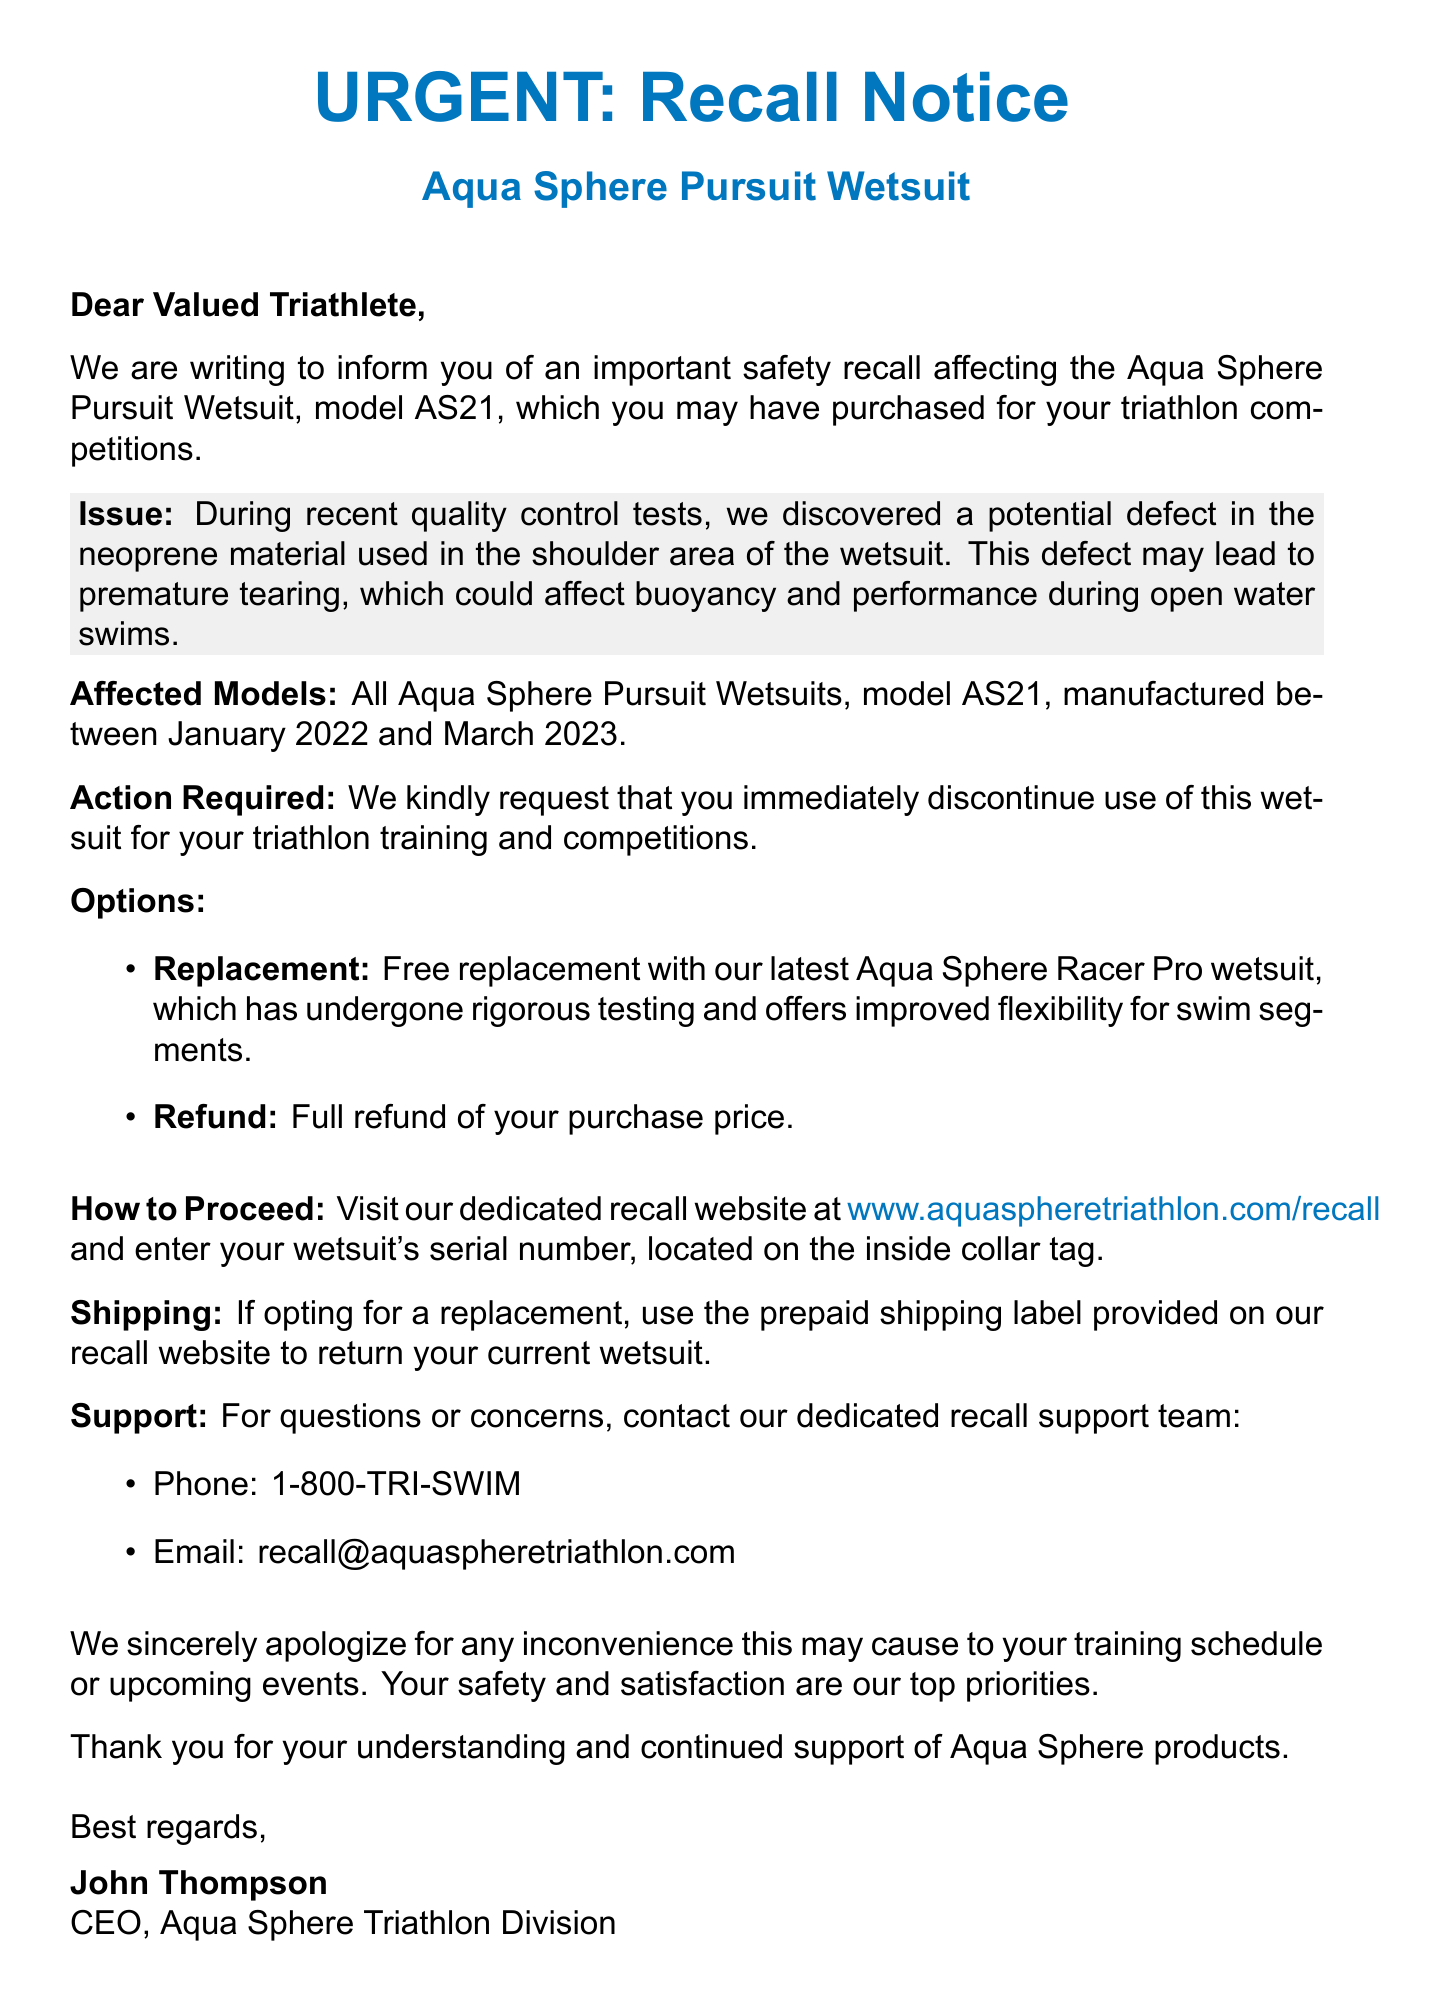What is the subject of the email? The subject states the purpose of the email, which is a recall notice for a specific wetsuit model.
Answer: URGENT: Recall Notice for Aqua Sphere Pursuit Wetsuit What is the model of the wetsuit being recalled? The model is specifically identified in the recall announcement of the email.
Answer: AS21 What defect was discovered in the wetsuit? The defect is described in detail in the issue description of the email.
Answer: Potential defect in the neoprene material What should I do if I have the affected wetsuit? The action required is clearly stated in the document for the recipients.
Answer: Discontinue use immediately What is the replacement option provided? The document offers an option for a replacement wetsuit, which is mentioned in the options section.
Answer: Aqua Sphere Racer Pro wetsuit What are the dates for the manufacturing of the affected models? The specific manufacturing dates are provided to identify the affected products.
Answer: January 2022 to March 2023 What is the contact number for customer support? The support details include a designated phone number for inquiries regarding the recall.
Answer: 1-800-TRI-SWIM What website should I visit for recall processing? The email specifies a website to help customers initiate the refund or replacement process.
Answer: www.aquaspheretriathlon.com/recall What is the CEO's name mentioned in the email? The closing includes the name of the CEO who signed off on the message.
Answer: John Thompson 